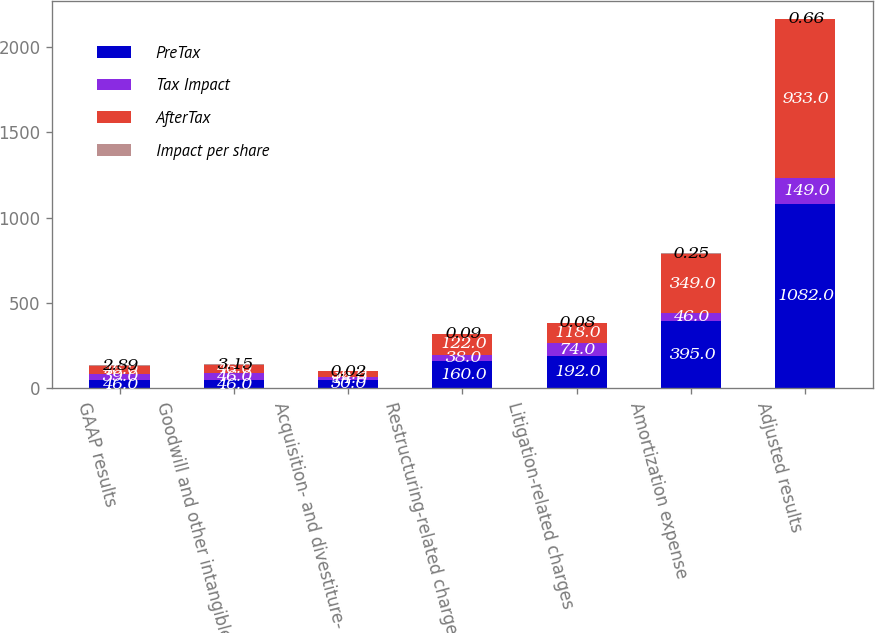<chart> <loc_0><loc_0><loc_500><loc_500><stacked_bar_chart><ecel><fcel>GAAP results<fcel>Goodwill and other intangible<fcel>Acquisition- and divestiture-<fcel>Restructuring-related charges<fcel>Litigation-related charges<fcel>Amortization expense<fcel>Adjusted results<nl><fcel>PreTax<fcel>46<fcel>46<fcel>50<fcel>160<fcel>192<fcel>395<fcel>1082<nl><fcel>Tax Impact<fcel>39<fcel>46<fcel>14<fcel>38<fcel>74<fcel>46<fcel>149<nl><fcel>AfterTax<fcel>46<fcel>46<fcel>36<fcel>122<fcel>118<fcel>349<fcel>933<nl><fcel>Impact per share<fcel>2.89<fcel>3.15<fcel>0.02<fcel>0.09<fcel>0.08<fcel>0.25<fcel>0.66<nl></chart> 